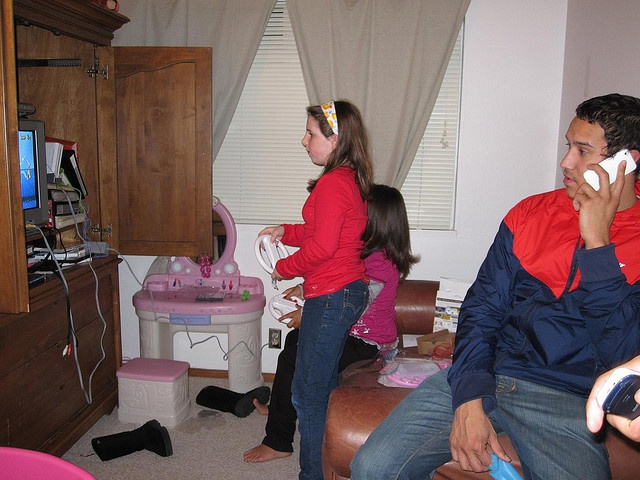Describe the objects in this image and their specific colors. I can see people in maroon, navy, black, gray, and red tones, people in maroon, navy, black, and brown tones, people in maroon, black, purple, and gray tones, couch in maroon, brown, and gray tones, and tv in maroon, black, gray, lightblue, and blue tones in this image. 